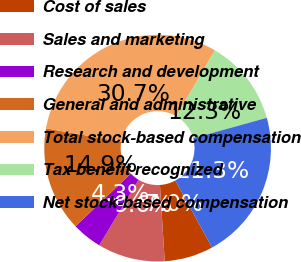<chart> <loc_0><loc_0><loc_500><loc_500><pie_chart><fcel>Cost of sales<fcel>Sales and marketing<fcel>Research and development<fcel>General and administrative<fcel>Total stock-based compensation<fcel>Tax benefit recognized<fcel>Net stock-based compensation<nl><fcel>6.97%<fcel>9.61%<fcel>4.28%<fcel>14.89%<fcel>30.66%<fcel>12.25%<fcel>21.33%<nl></chart> 